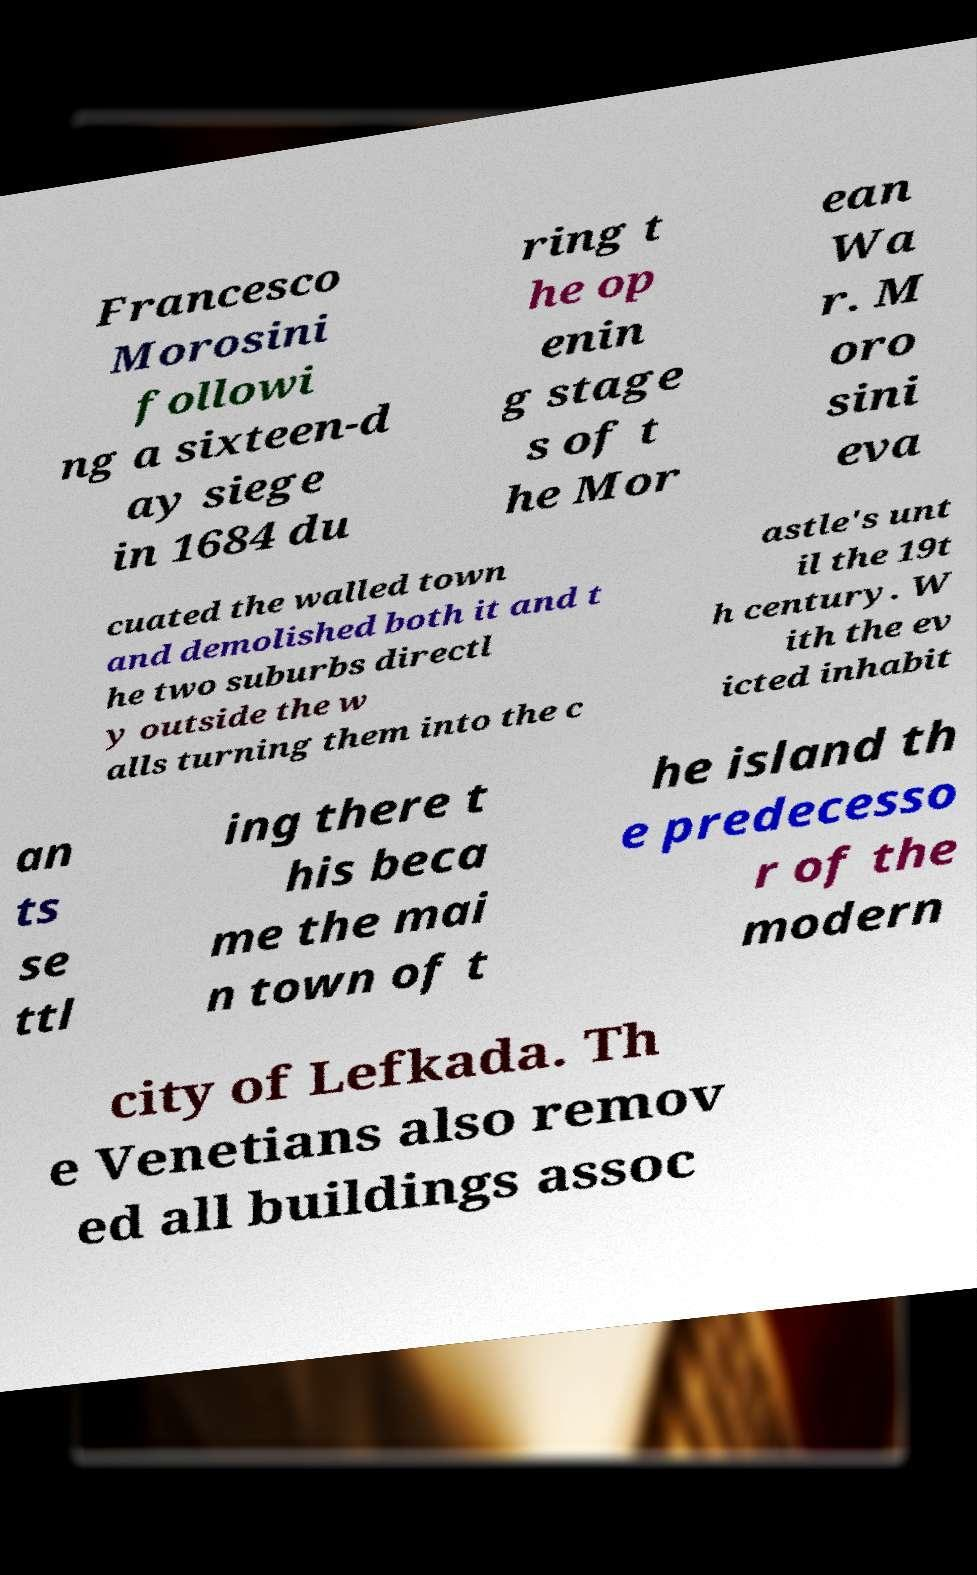Could you assist in decoding the text presented in this image and type it out clearly? Francesco Morosini followi ng a sixteen-d ay siege in 1684 du ring t he op enin g stage s of t he Mor ean Wa r. M oro sini eva cuated the walled town and demolished both it and t he two suburbs directl y outside the w alls turning them into the c astle's unt il the 19t h century. W ith the ev icted inhabit an ts se ttl ing there t his beca me the mai n town of t he island th e predecesso r of the modern city of Lefkada. Th e Venetians also remov ed all buildings assoc 